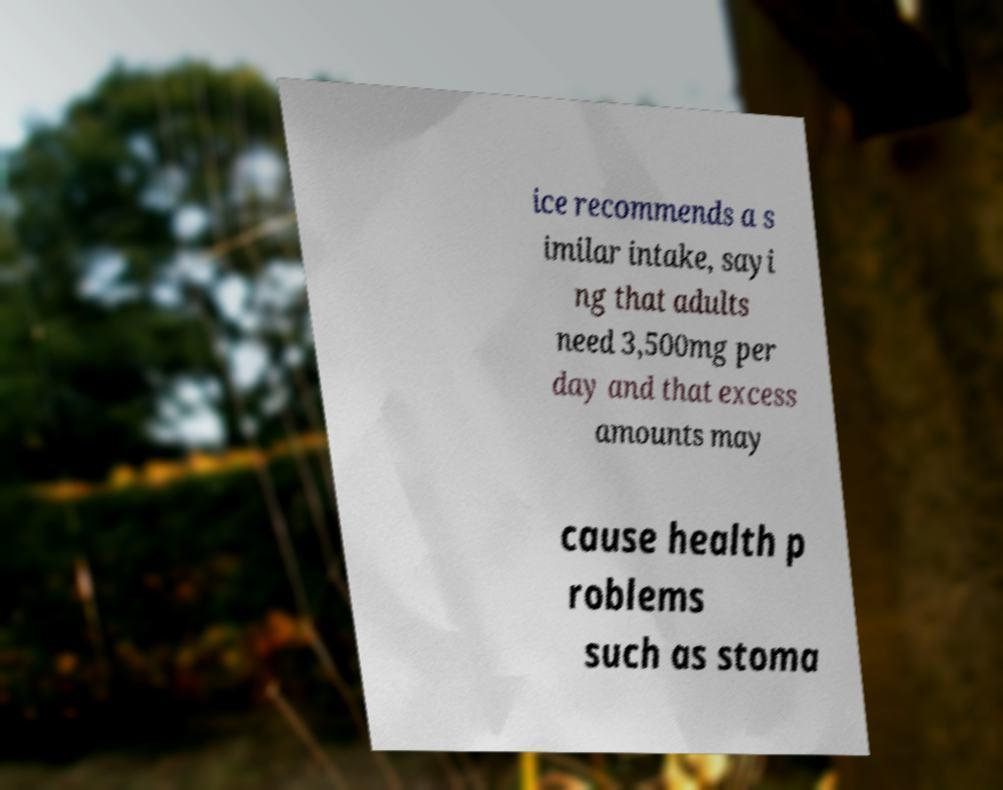What messages or text are displayed in this image? I need them in a readable, typed format. ice recommends a s imilar intake, sayi ng that adults need 3,500mg per day and that excess amounts may cause health p roblems such as stoma 